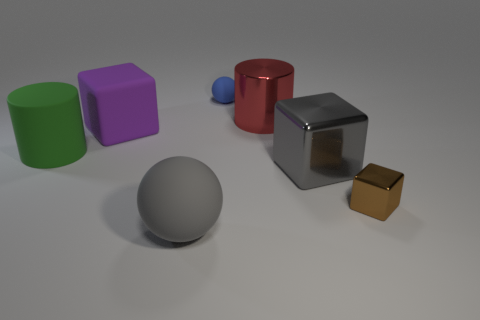Does the large matte object that is in front of the small brown metal cube have the same shape as the gray shiny object?
Your response must be concise. No. Are there any blue cylinders of the same size as the red metallic cylinder?
Make the answer very short. No. There is a blue matte object; does it have the same shape as the gray object to the right of the tiny ball?
Offer a terse response. No. The large thing that is the same color as the big rubber sphere is what shape?
Provide a short and direct response. Cube. Is the number of matte cylinders in front of the large green cylinder less than the number of things?
Your answer should be very brief. Yes. Is the shape of the tiny blue rubber thing the same as the big gray matte object?
Your answer should be compact. Yes. There is a gray object that is made of the same material as the large green object; what is its size?
Provide a succinct answer. Large. Are there fewer gray shiny objects than blue cubes?
Your answer should be compact. No. How many small things are brown cylinders or gray metal things?
Provide a succinct answer. 0. What number of things are behind the gray metal block and in front of the blue rubber ball?
Your response must be concise. 3. 